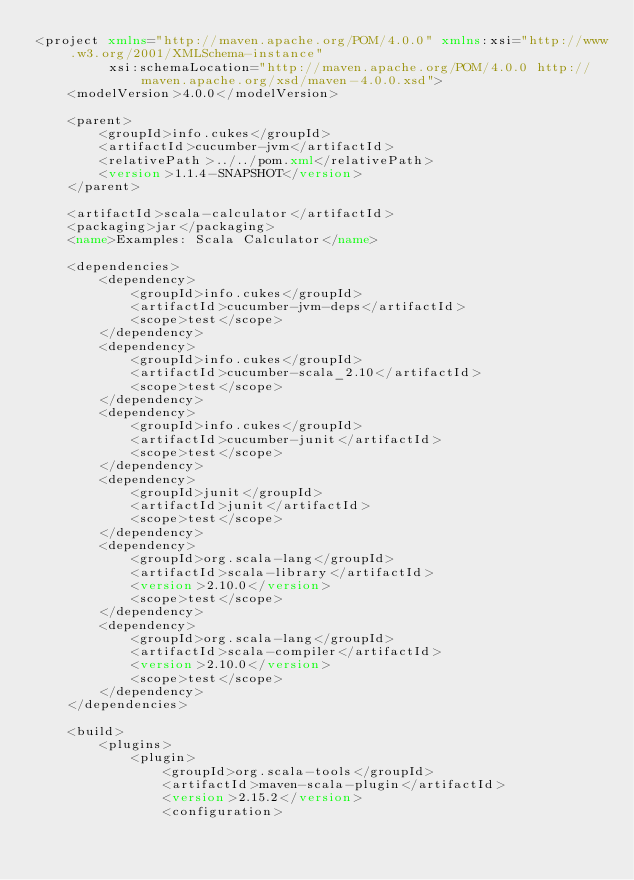<code> <loc_0><loc_0><loc_500><loc_500><_XML_><project xmlns="http://maven.apache.org/POM/4.0.0" xmlns:xsi="http://www.w3.org/2001/XMLSchema-instance"
         xsi:schemaLocation="http://maven.apache.org/POM/4.0.0 http://maven.apache.org/xsd/maven-4.0.0.xsd">
    <modelVersion>4.0.0</modelVersion>

    <parent>
        <groupId>info.cukes</groupId>
        <artifactId>cucumber-jvm</artifactId>
        <relativePath>../../pom.xml</relativePath>
        <version>1.1.4-SNAPSHOT</version>
    </parent>

    <artifactId>scala-calculator</artifactId>
    <packaging>jar</packaging>
    <name>Examples: Scala Calculator</name>

    <dependencies>
        <dependency>
            <groupId>info.cukes</groupId>
            <artifactId>cucumber-jvm-deps</artifactId>
            <scope>test</scope>
        </dependency>
        <dependency>
            <groupId>info.cukes</groupId>
            <artifactId>cucumber-scala_2.10</artifactId>
            <scope>test</scope>
        </dependency>
        <dependency>
            <groupId>info.cukes</groupId>
            <artifactId>cucumber-junit</artifactId>
            <scope>test</scope>
        </dependency>
        <dependency>
            <groupId>junit</groupId>
            <artifactId>junit</artifactId>
            <scope>test</scope>
        </dependency>
        <dependency>
            <groupId>org.scala-lang</groupId>
            <artifactId>scala-library</artifactId>
            <version>2.10.0</version>
            <scope>test</scope>
        </dependency>
        <dependency>
            <groupId>org.scala-lang</groupId>
            <artifactId>scala-compiler</artifactId>
            <version>2.10.0</version>
            <scope>test</scope>
        </dependency>
    </dependencies>

    <build>
        <plugins>
            <plugin>
                <groupId>org.scala-tools</groupId>
                <artifactId>maven-scala-plugin</artifactId>
                <version>2.15.2</version>
                <configuration></code> 